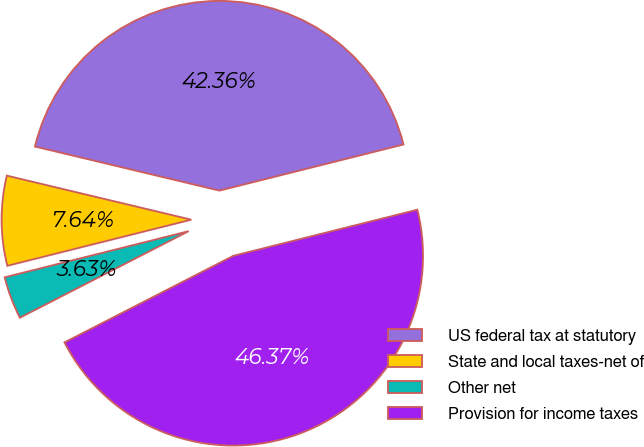Convert chart. <chart><loc_0><loc_0><loc_500><loc_500><pie_chart><fcel>US federal tax at statutory<fcel>State and local taxes-net of<fcel>Other net<fcel>Provision for income taxes<nl><fcel>42.36%<fcel>7.64%<fcel>3.63%<fcel>46.37%<nl></chart> 